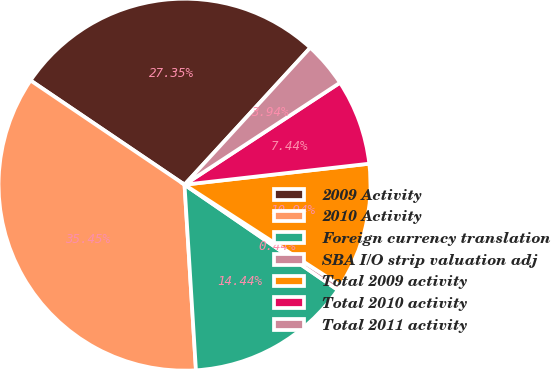Convert chart. <chart><loc_0><loc_0><loc_500><loc_500><pie_chart><fcel>2009 Activity<fcel>2010 Activity<fcel>Foreign currency translation<fcel>SBA I/O strip valuation adj<fcel>Total 2009 activity<fcel>Total 2010 activity<fcel>Total 2011 activity<nl><fcel>27.35%<fcel>35.45%<fcel>14.44%<fcel>0.44%<fcel>10.94%<fcel>7.44%<fcel>3.94%<nl></chart> 